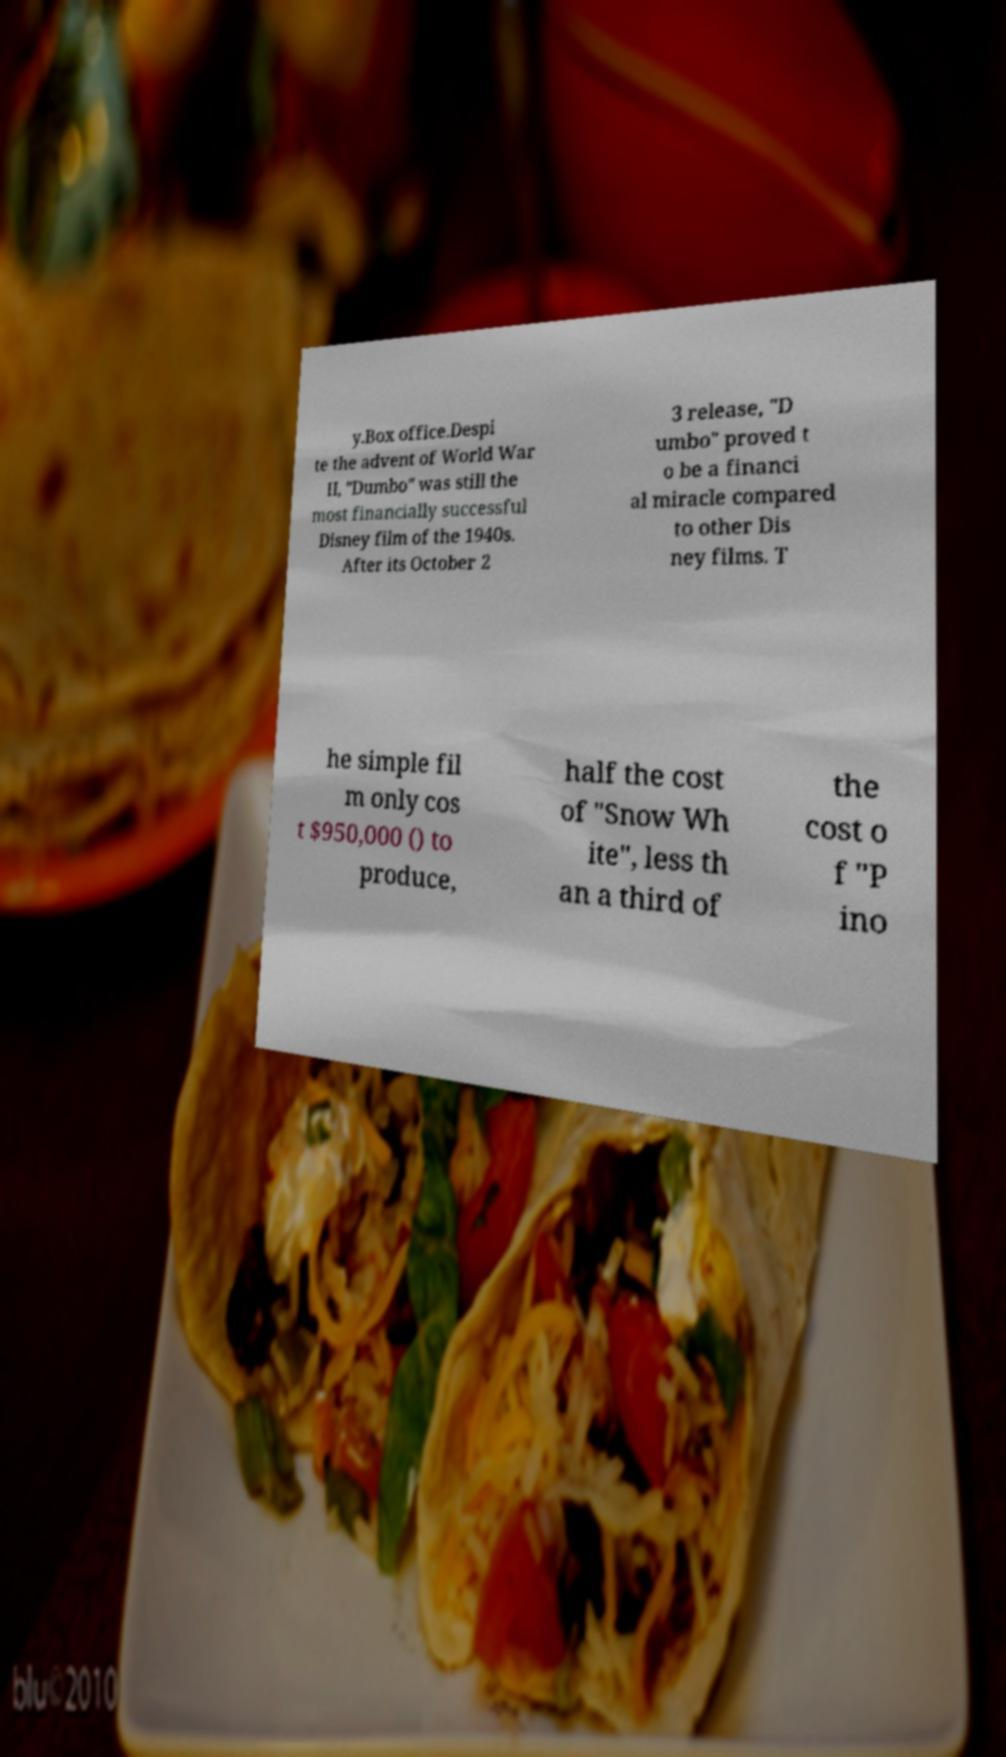Could you extract and type out the text from this image? y.Box office.Despi te the advent of World War II, "Dumbo" was still the most financially successful Disney film of the 1940s. After its October 2 3 release, "D umbo" proved t o be a financi al miracle compared to other Dis ney films. T he simple fil m only cos t $950,000 () to produce, half the cost of "Snow Wh ite", less th an a third of the cost o f "P ino 